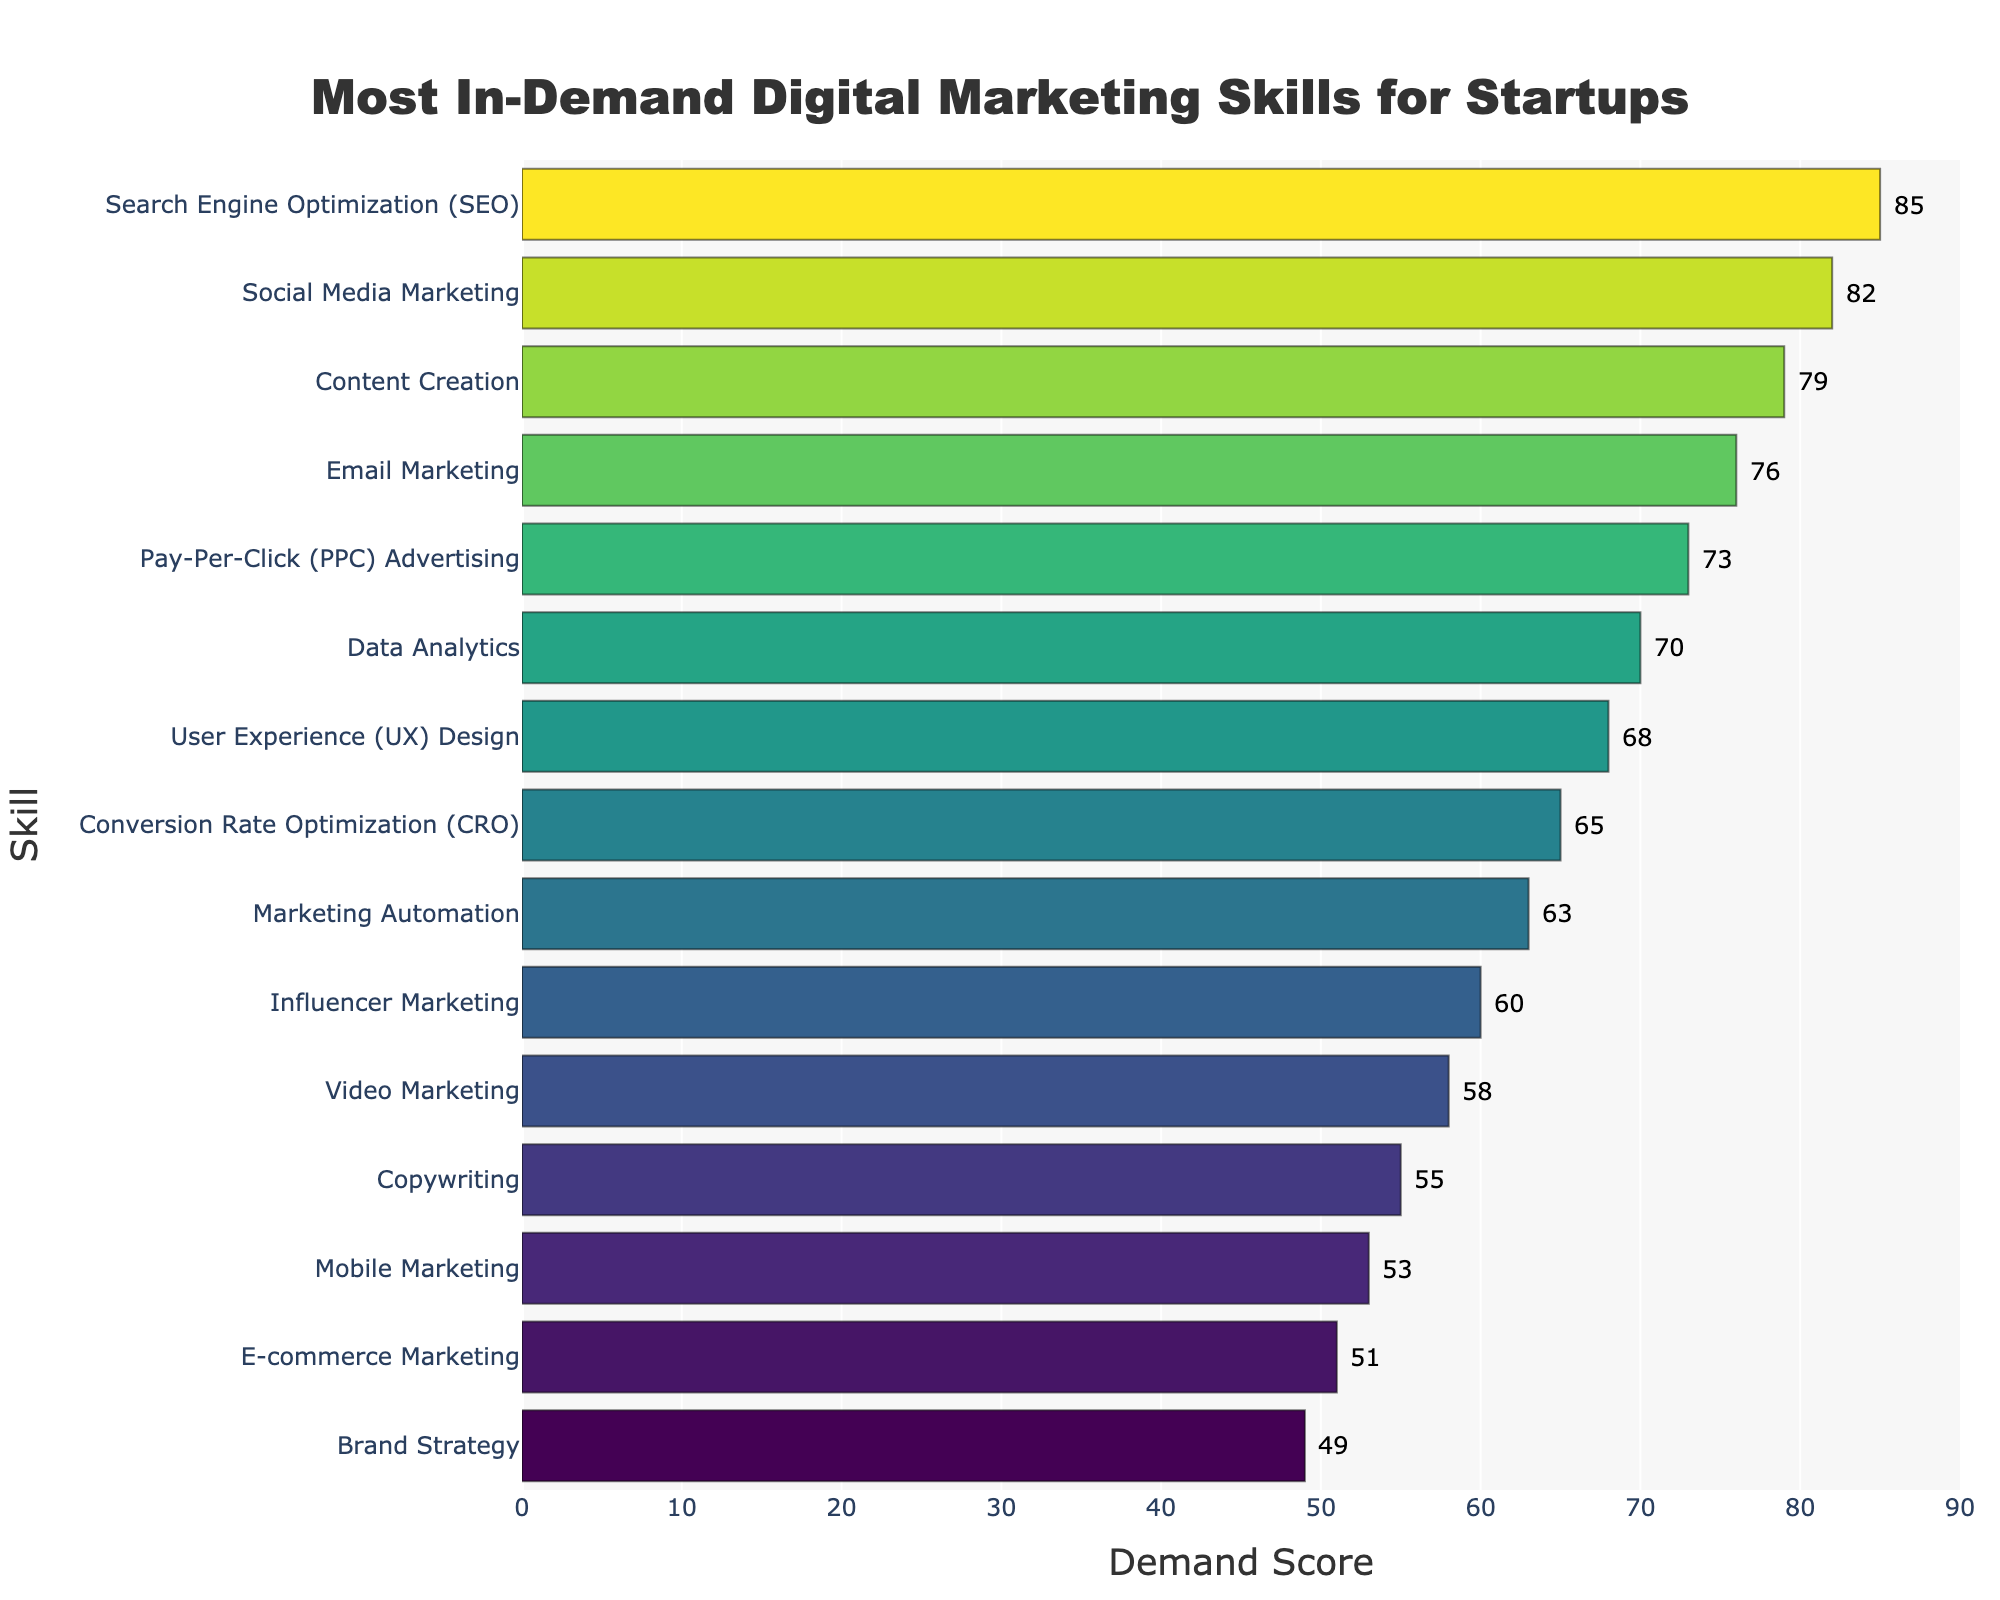what skill has the highest demand score? The bar chart displays various skills along with their demand scores. The tallest bar represents the skill with the highest demand score, which is at the top.
Answer: Search Engine Optimization (SEO) Which skills have a demand score greater than 80? By observing the bars that extend past the 80 mark on the x-axis, we can identify the skills with a demand score greater than 80.
Answer: Search Engine Optimization (SEO), Social Media Marketing What is the difference in demand scores between Content Creation and Email Marketing? To find the difference, refer to the specific bars for Content Creation (79) and Email Marketing (76) and subtract the smaller from the larger score. 79 - 76 = 3
Answer: 3 What is the average demand score of the top 5 skills? First identify the top 5 skills: SEO (85), Social Media Marketing (82), Content Creation (79), Email Marketing (76), PPC Advertising (73). Then calculate their average: (85 + 82 + 79 + 76 + 73)/5 = 79
Answer: 79 Which skill is most visually similar in height to Email Marketing? The visual attribute (height) of the bars represents the demand scores. The bar closest in height to Email Marketing (76) is the one for PPC Advertising (73).
Answer: Pay-Per-Click (PPC) Advertising What are the demand scores for the skills with the shortest and tallest bars? By identifying the shortest (Brand Strategy) and tallest (SEO) bars, we refer to their demand scores annotated on the plot. The scores are 49 and 85, respectively.
Answer: 49 and 85 How much higher is User Experience (UX) Design in demand compared to E-commerce Marketing? Locate the bars for User Experience (UX) Design (68) and E-commerce Marketing (51) and find the difference between their scores: 68 - 51 = 17
Answer: 17 Which skills have a demand score between 60 and 70? Identify and list the bars falling between the 60 and 70 marks on the x-axis. Skills in this range are: Data Analytics (70), User Experience (UX) Design (68), Conversion Rate Optimization (CRO) (65).
Answer: Data Analytics, User Experience (UX) Design, Conversion Rate Optimization (CRO) If Brand Strategy and Content Creation were to switch demand scores, what would the new difference be? First determine the current scores: Brand Strategy (49) and Content Creation (79). If they switch, Brand Strategy becomes 79 and Content Creation becomes 49. New difference: 79 - 49 = 30
Answer: 30 